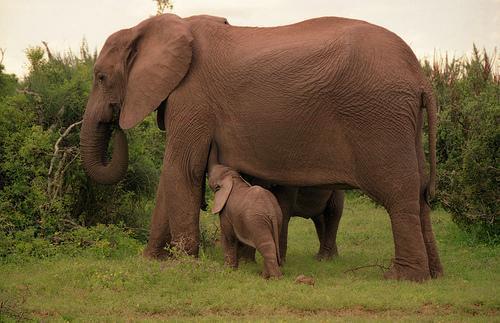How many elephants are there?
Give a very brief answer. 3. 